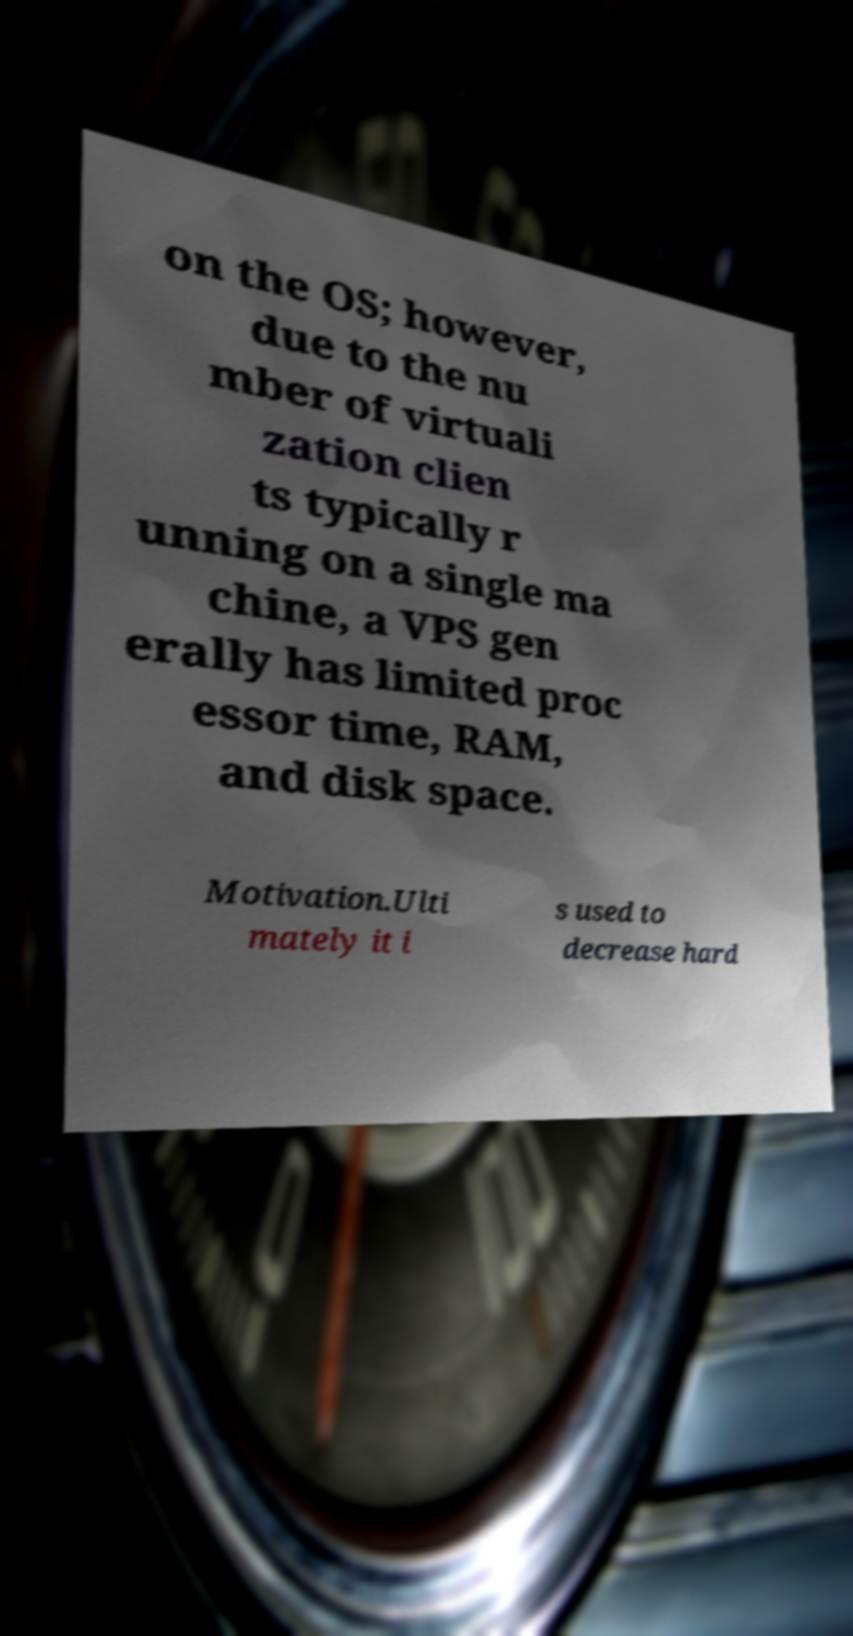There's text embedded in this image that I need extracted. Can you transcribe it verbatim? on the OS; however, due to the nu mber of virtuali zation clien ts typically r unning on a single ma chine, a VPS gen erally has limited proc essor time, RAM, and disk space. Motivation.Ulti mately it i s used to decrease hard 